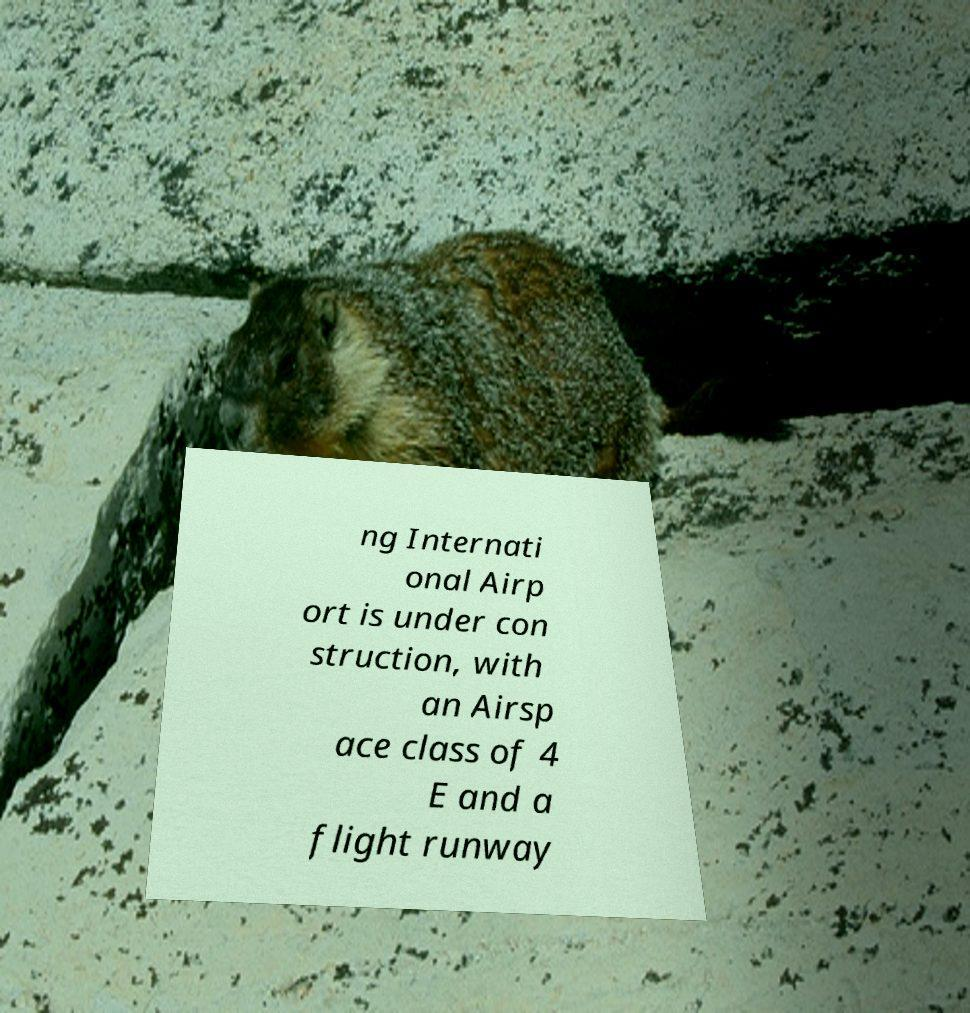Can you read and provide the text displayed in the image?This photo seems to have some interesting text. Can you extract and type it out for me? ng Internati onal Airp ort is under con struction, with an Airsp ace class of 4 E and a flight runway 